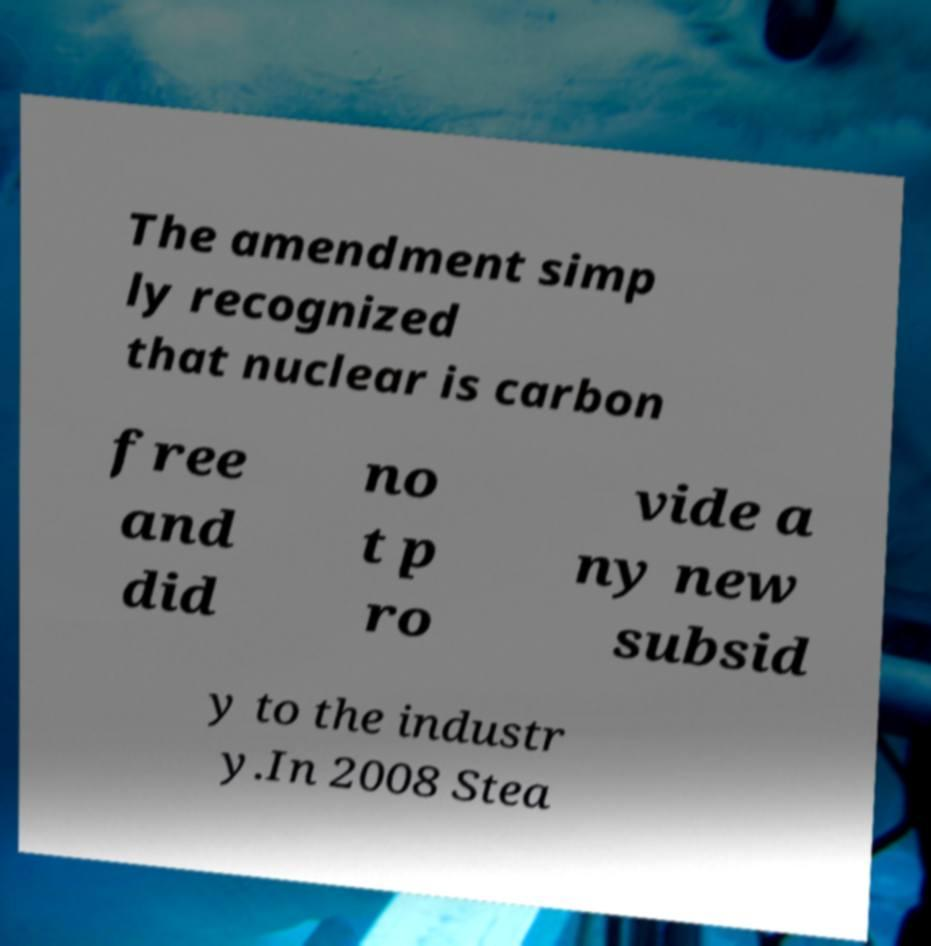For documentation purposes, I need the text within this image transcribed. Could you provide that? The amendment simp ly recognized that nuclear is carbon free and did no t p ro vide a ny new subsid y to the industr y.In 2008 Stea 